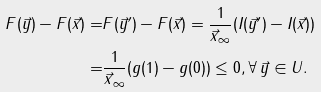<formula> <loc_0><loc_0><loc_500><loc_500>F ( \vec { y } ) - F ( \vec { x } ) = & F ( \vec { y } ^ { \prime } ) - F ( \vec { x } ) = \frac { 1 } { \| \vec { x } \| _ { \infty } } ( I ( \vec { y } ^ { \prime } ) - I ( \vec { x } ) ) \\ = & \frac { 1 } { \| \vec { x } \| _ { \infty } } ( g ( 1 ) - g ( 0 ) ) \leq 0 , \forall \, \vec { y } \in U .</formula> 